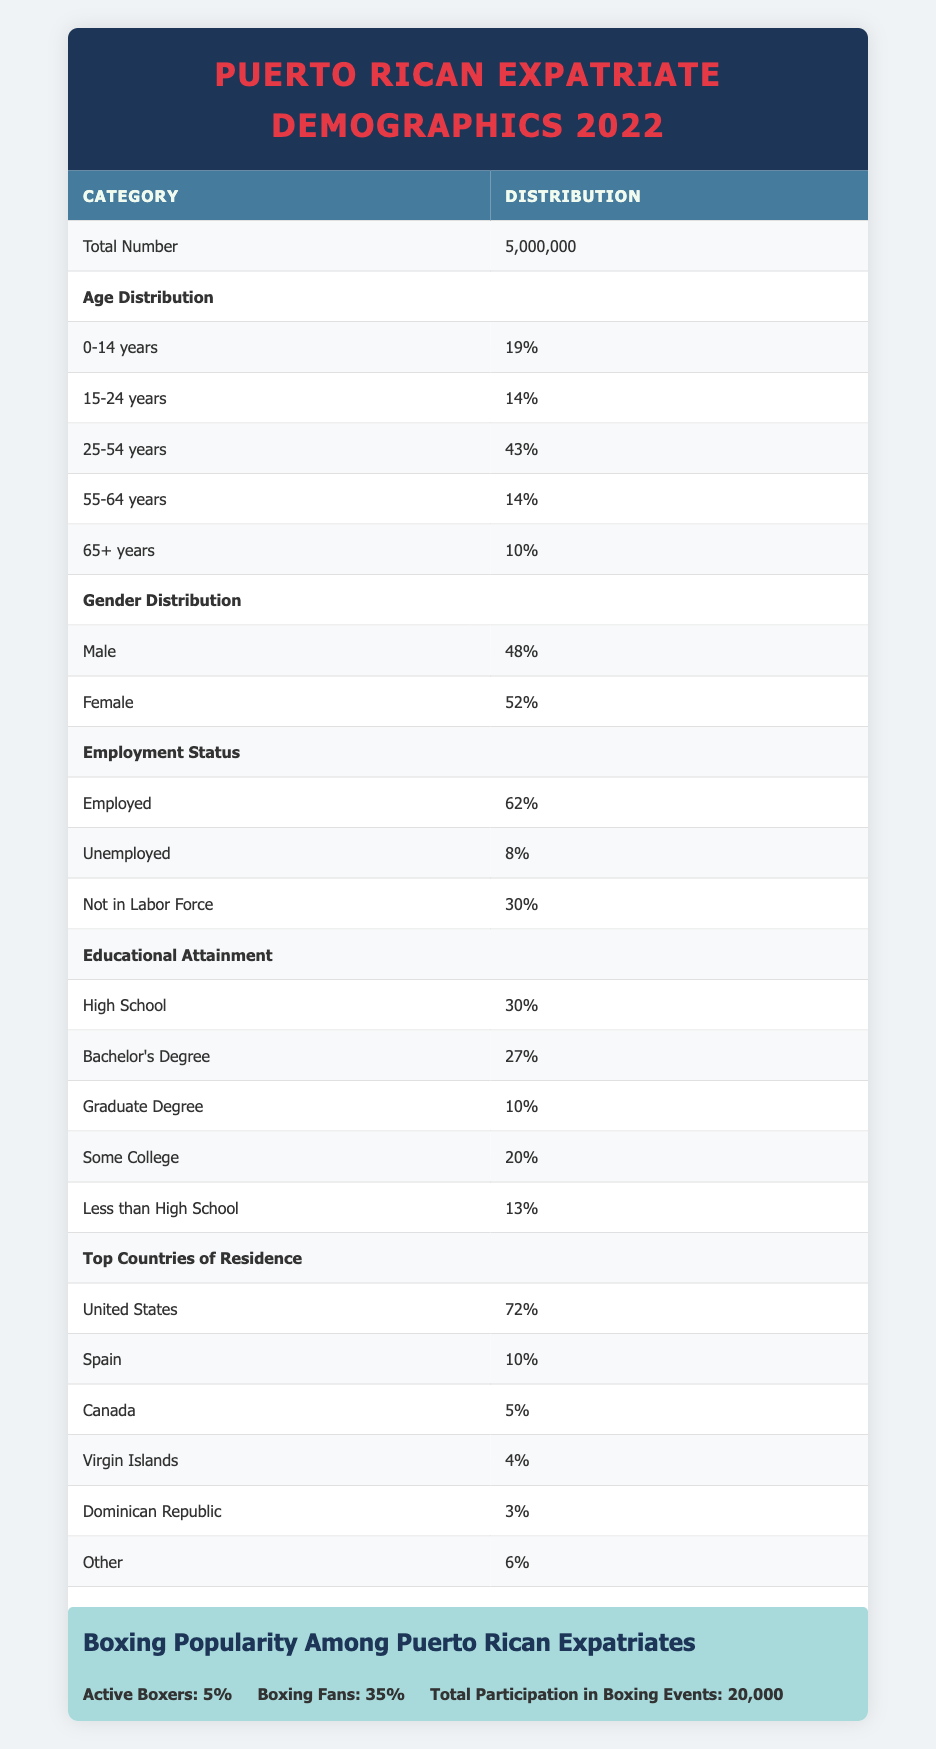What is the total number of Puerto Ricans living abroad in 2022? The "Total Number" category in the table lists 5,000,000, which denotes the total count of Puerto Ricans residing outside Puerto Rico in that year.
Answer: 5,000,000 What percentage of the demographic is between the ages of 25 and 54? To find the percentage of Puerto Ricans aged 25-54, we look at the "Age Distribution" section where 43% of the population falls into this age category.
Answer: 43% Are there more females than males among Puerto Ricans living abroad? The table shows that females constitute 52% while males represent 48%. Since 52% is greater than 48%, the statement is true.
Answer: Yes What is the percentage of Puerto Ricans who are unemployed? The "Employment Status" section lists that 8% of the Puerto Rican demographic abroad are unemployed, directly answering the question.
Answer: 8% What percentage of Puerto Ricans abroad have attained a graduate degree? In the "Educational Attainment" section, it is mentioned that 10% of the population has a graduate degree. This directly answers the question.
Answer: 10% How many percent of Puerto Ricans living abroad are either unemployed or not in the labor force? To find this, we sum the unemployment percentage (8%) and those not in the labor force (30%). Thus, 8% + 30% = 38%.
Answer: 38% What is the total percentage of Puerto Ricans living abroad who reside in the United States and Canada combined? We look at the "Top Countries of Residence" where 72% live in the United States and 5% in Canada. Adding these together gives us 72% + 5% = 77%.
Answer: 77% Is it true that the majority of Puerto Ricans living abroad have at least a high school education? In the "Educational Attainment" section, only 13% have less than a high school education, meaning 87% have at least completed high school. Hence, the statement is true.
Answer: Yes What is the difference between the percentage of boxing fans and active boxers among Puerto Ricans living abroad? The "Boxing Popularity" section shows 35% are fans and 5% are active boxers. Thus, the difference is 35% - 5% = 30%.
Answer: 30% 